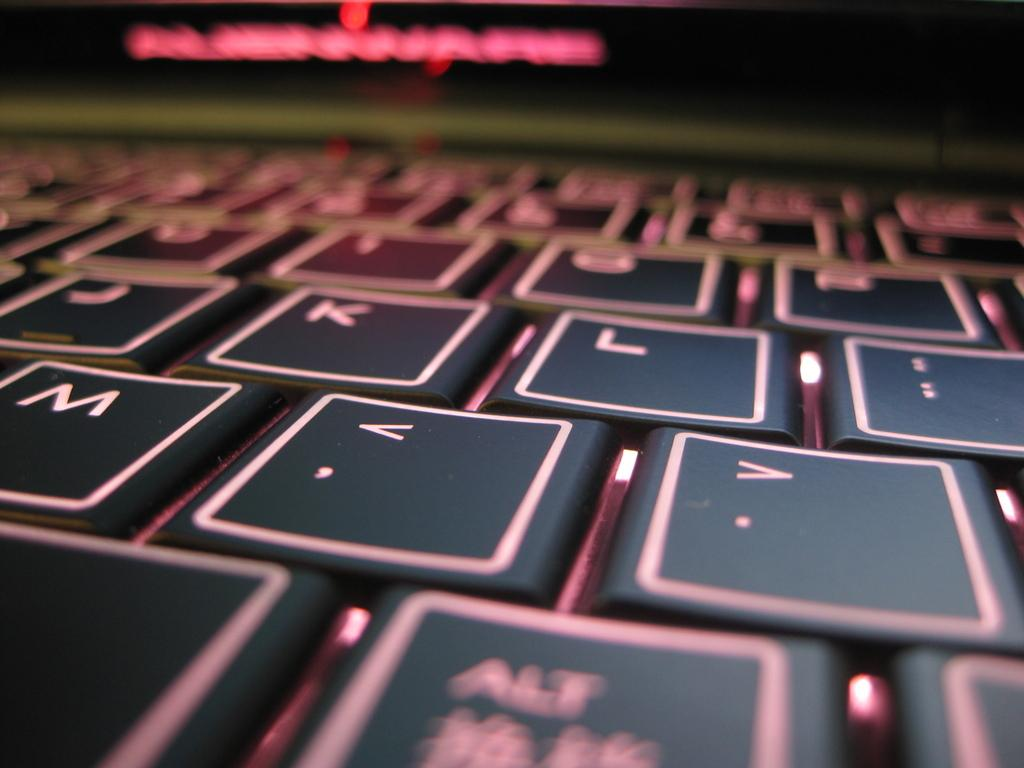<image>
Present a compact description of the photo's key features. Partial shot of a flat keyboard with J, k, L and M displayed. 